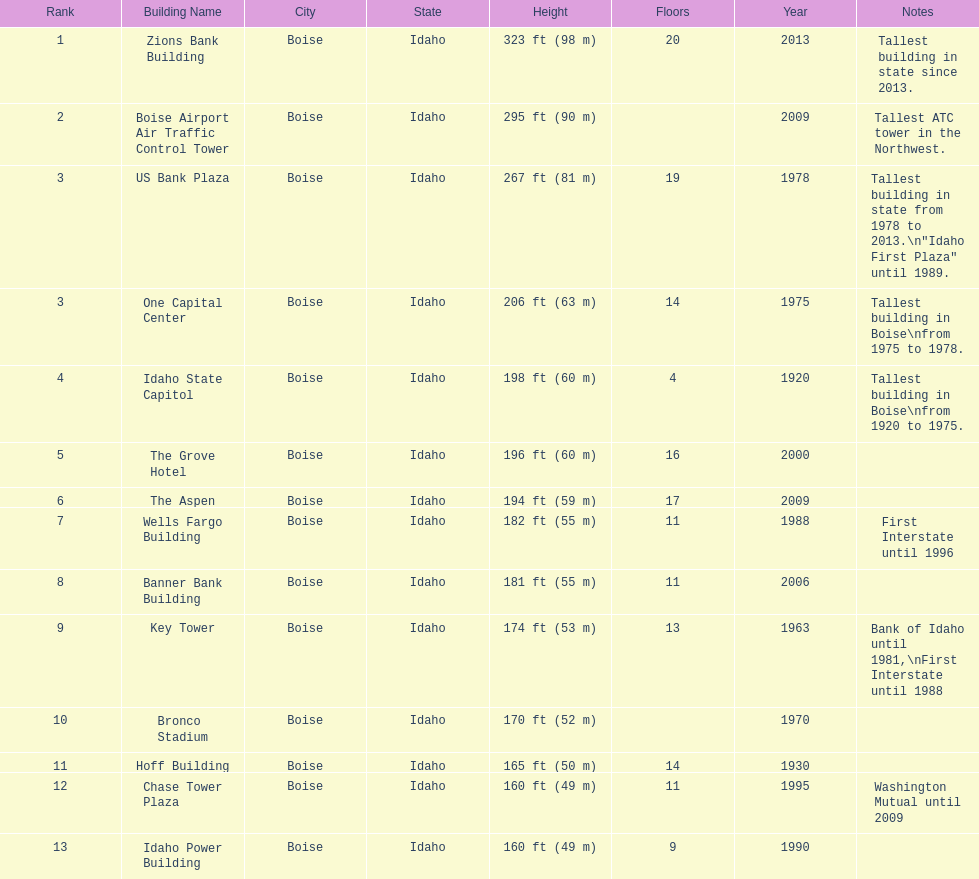How many of these buildings were built after 1975 8. 